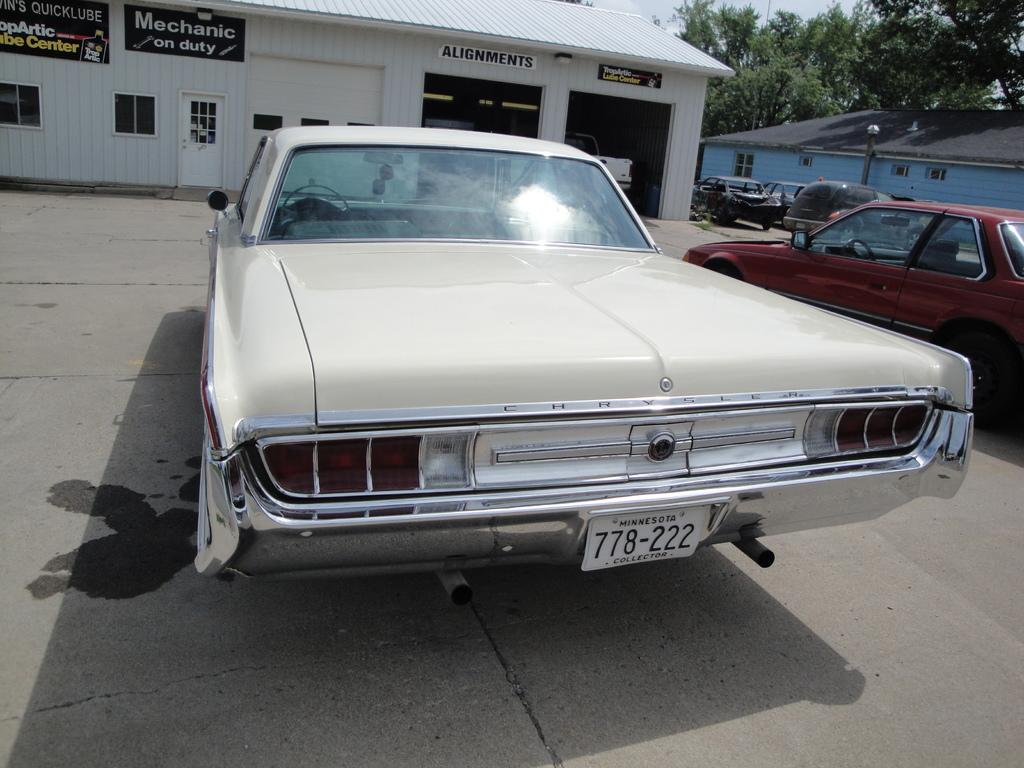What can be seen on the road in the image? There are vehicles on the road in the image. What type of structures are present in the image? There are sheds in the image. What objects are visible in the image that might be used for displaying information or advertisements? There are boards in the image. What can be seen providing illumination in the image? There are lights in the image. What type of natural vegetation is present in the image? There are trees in the image. What is visible in the background of the image? The sky is visible in the image. Can you tell me how many snails are crawling on the sidewalk in the image? There is no sidewalk or snails present in the image. What type of paste is being used to stick the boards to the sheds in the image? There is no mention of paste or any adhesive being used to attach the boards to the sheds in the image. 